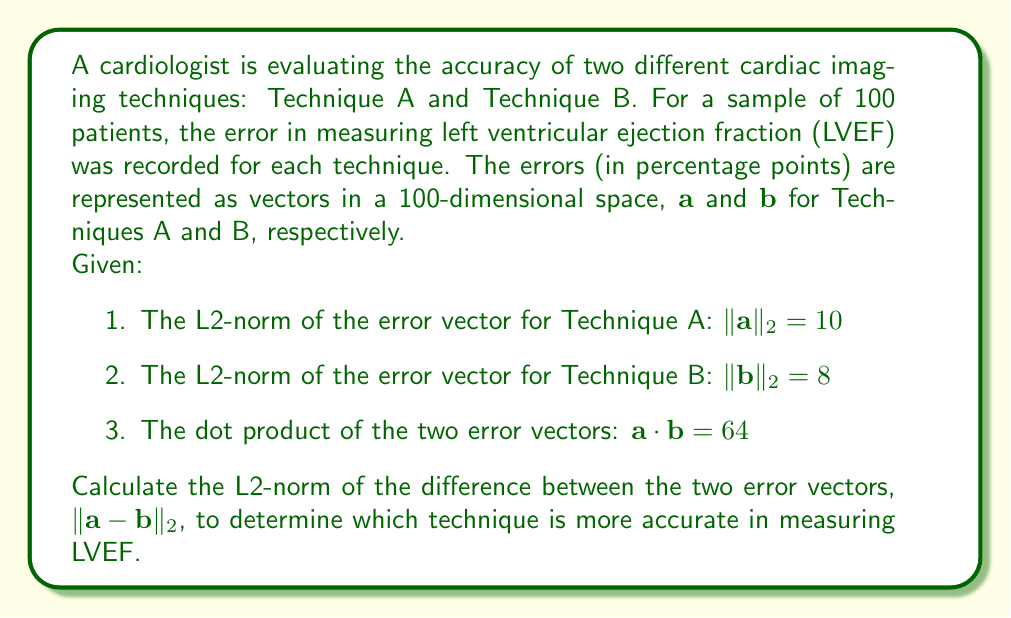Give your solution to this math problem. To solve this problem, we'll use the properties of vector norms and dot products in a Hilbert space. The L2-norm of the difference between two vectors can be calculated using the following formula:

$$\|\mathbf{a} - \mathbf{b}\|_2^2 = \|\mathbf{a}\|_2^2 + \|\mathbf{b}\|_2^2 - 2(\mathbf{a} \cdot \mathbf{b})$$

Let's break down the solution step-by-step:

1. We're given $\|\mathbf{a}\|_2 = 10$ and $\|\mathbf{b}\|_2 = 8$. We need to square these values:
   $\|\mathbf{a}\|_2^2 = 10^2 = 100$
   $\|\mathbf{b}\|_2^2 = 8^2 = 64$

2. We're also given $\mathbf{a} \cdot \mathbf{b} = 64$

3. Now, let's substitute these values into our formula:
   $$\|\mathbf{a} - \mathbf{b}\|_2^2 = 100 + 64 - 2(64) = 164 - 128 = 36$$

4. To get the L2-norm, we need to take the square root of this result:
   $$\|\mathbf{a} - \mathbf{b}\|_2 = \sqrt{36} = 6$$

5. Interpretation: The L2-norm of the difference between the two error vectors is 6 percentage points. This represents the overall difference in accuracy between the two techniques across all 100 patients.

6. To determine which technique is more accurate, we compare their individual L2-norms:
   Technique A: $\|\mathbf{a}\|_2 = 10$
   Technique B: $\|\mathbf{b}\|_2 = 8$

   Since Technique B has a smaller L2-norm, it is more accurate in measuring LVEF.
Answer: The L2-norm of the difference between the two error vectors is $\|\mathbf{a} - \mathbf{b}\|_2 = 6$ percentage points. Technique B is more accurate in measuring LVEF as it has a smaller L2-norm ($\|\mathbf{b}\|_2 = 8$ compared to $\|\mathbf{a}\|_2 = 10$). 